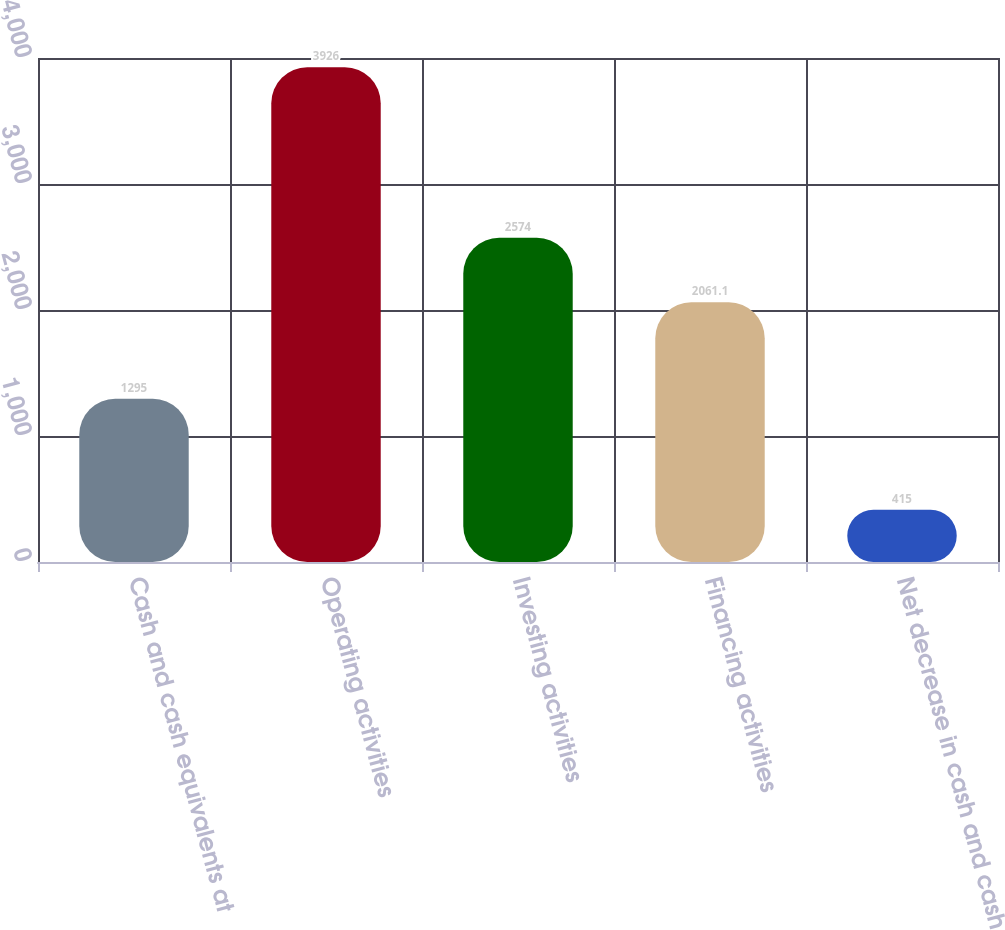Convert chart. <chart><loc_0><loc_0><loc_500><loc_500><bar_chart><fcel>Cash and cash equivalents at<fcel>Operating activities<fcel>Investing activities<fcel>Financing activities<fcel>Net decrease in cash and cash<nl><fcel>1295<fcel>3926<fcel>2574<fcel>2061.1<fcel>415<nl></chart> 